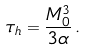Convert formula to latex. <formula><loc_0><loc_0><loc_500><loc_500>\tau _ { h } = \frac { M _ { 0 } ^ { 3 } } { 3 \alpha } \, .</formula> 